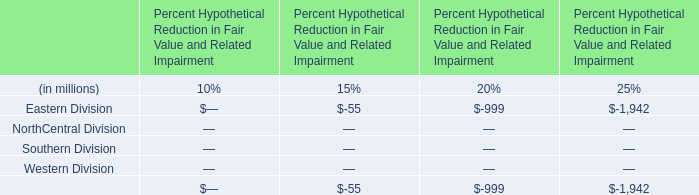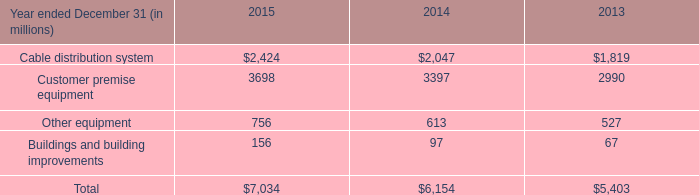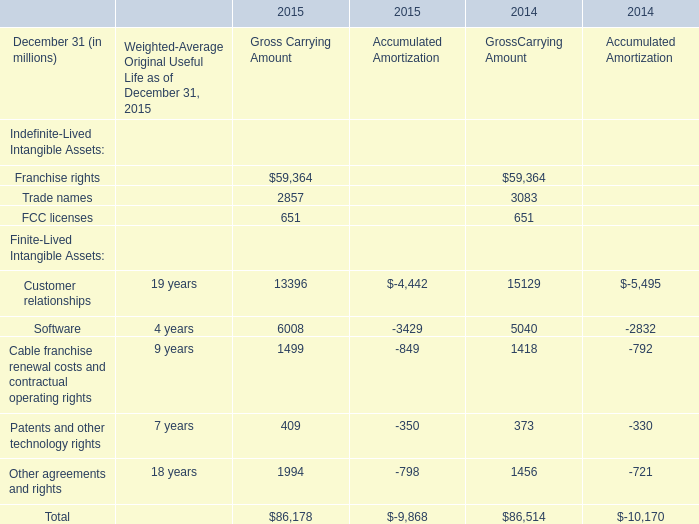What's the growth rate of Trade names for Gross Carrying Amount in 2014 for Gross Carrying Amount? 
Computations: ((3083 - 2857) / 3083)
Answer: 0.07331. 